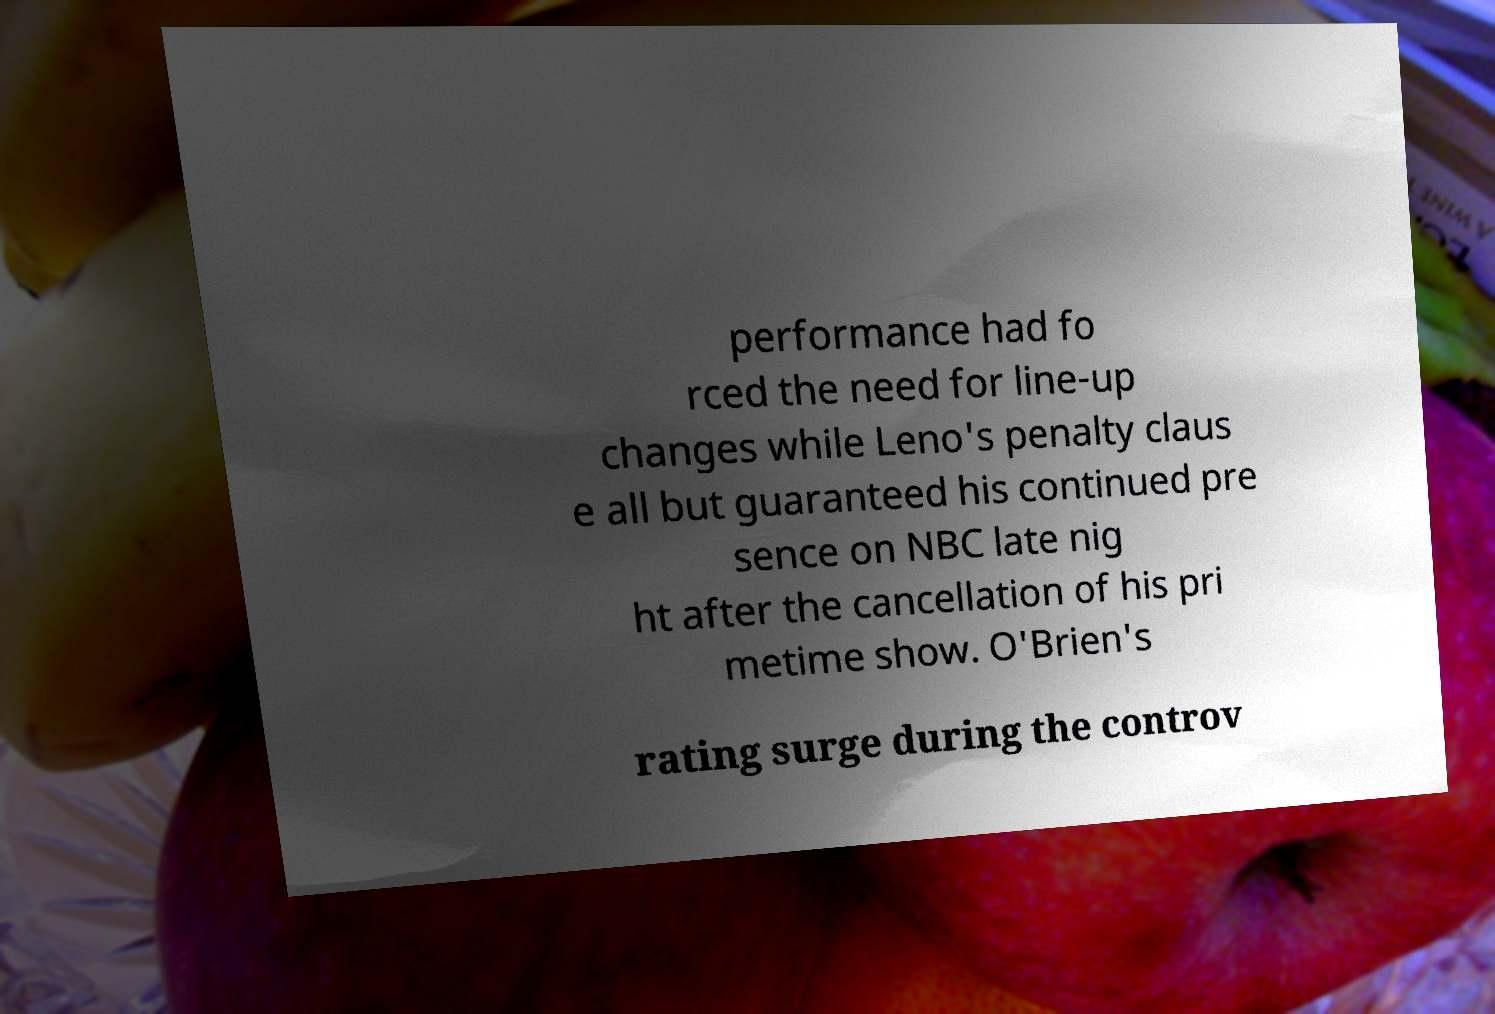I need the written content from this picture converted into text. Can you do that? performance had fo rced the need for line-up changes while Leno's penalty claus e all but guaranteed his continued pre sence on NBC late nig ht after the cancellation of his pri metime show. O'Brien's rating surge during the controv 